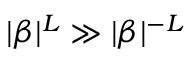<formula> <loc_0><loc_0><loc_500><loc_500>| \beta | ^ { L } \gg | \beta | ^ { - L }</formula> 